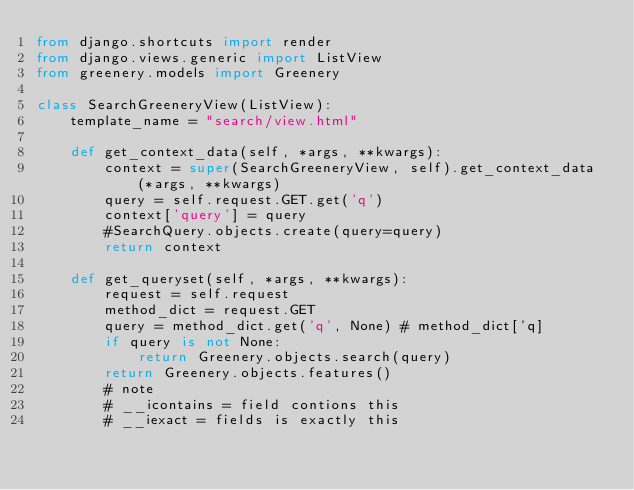<code> <loc_0><loc_0><loc_500><loc_500><_Python_>from django.shortcuts import render
from django.views.generic import ListView
from greenery.models import Greenery

class SearchGreeneryView(ListView):
    template_name = "search/view.html"

    def get_context_data(self, *args, **kwargs):
        context = super(SearchGreeneryView, self).get_context_data(*args, **kwargs)
        query = self.request.GET.get('q')
        context['query'] = query
        #SearchQuery.objects.create(query=query)
        return context

    def get_queryset(self, *args, **kwargs):
        request = self.request
        method_dict = request.GET
        query = method_dict.get('q', None) # method_dict['q]
        if query is not None:
            return Greenery.objects.search(query)
        return Greenery.objects.features()
        # note
        # __icontains = field contions this
        # __iexact = fields is exactly this

        
</code> 